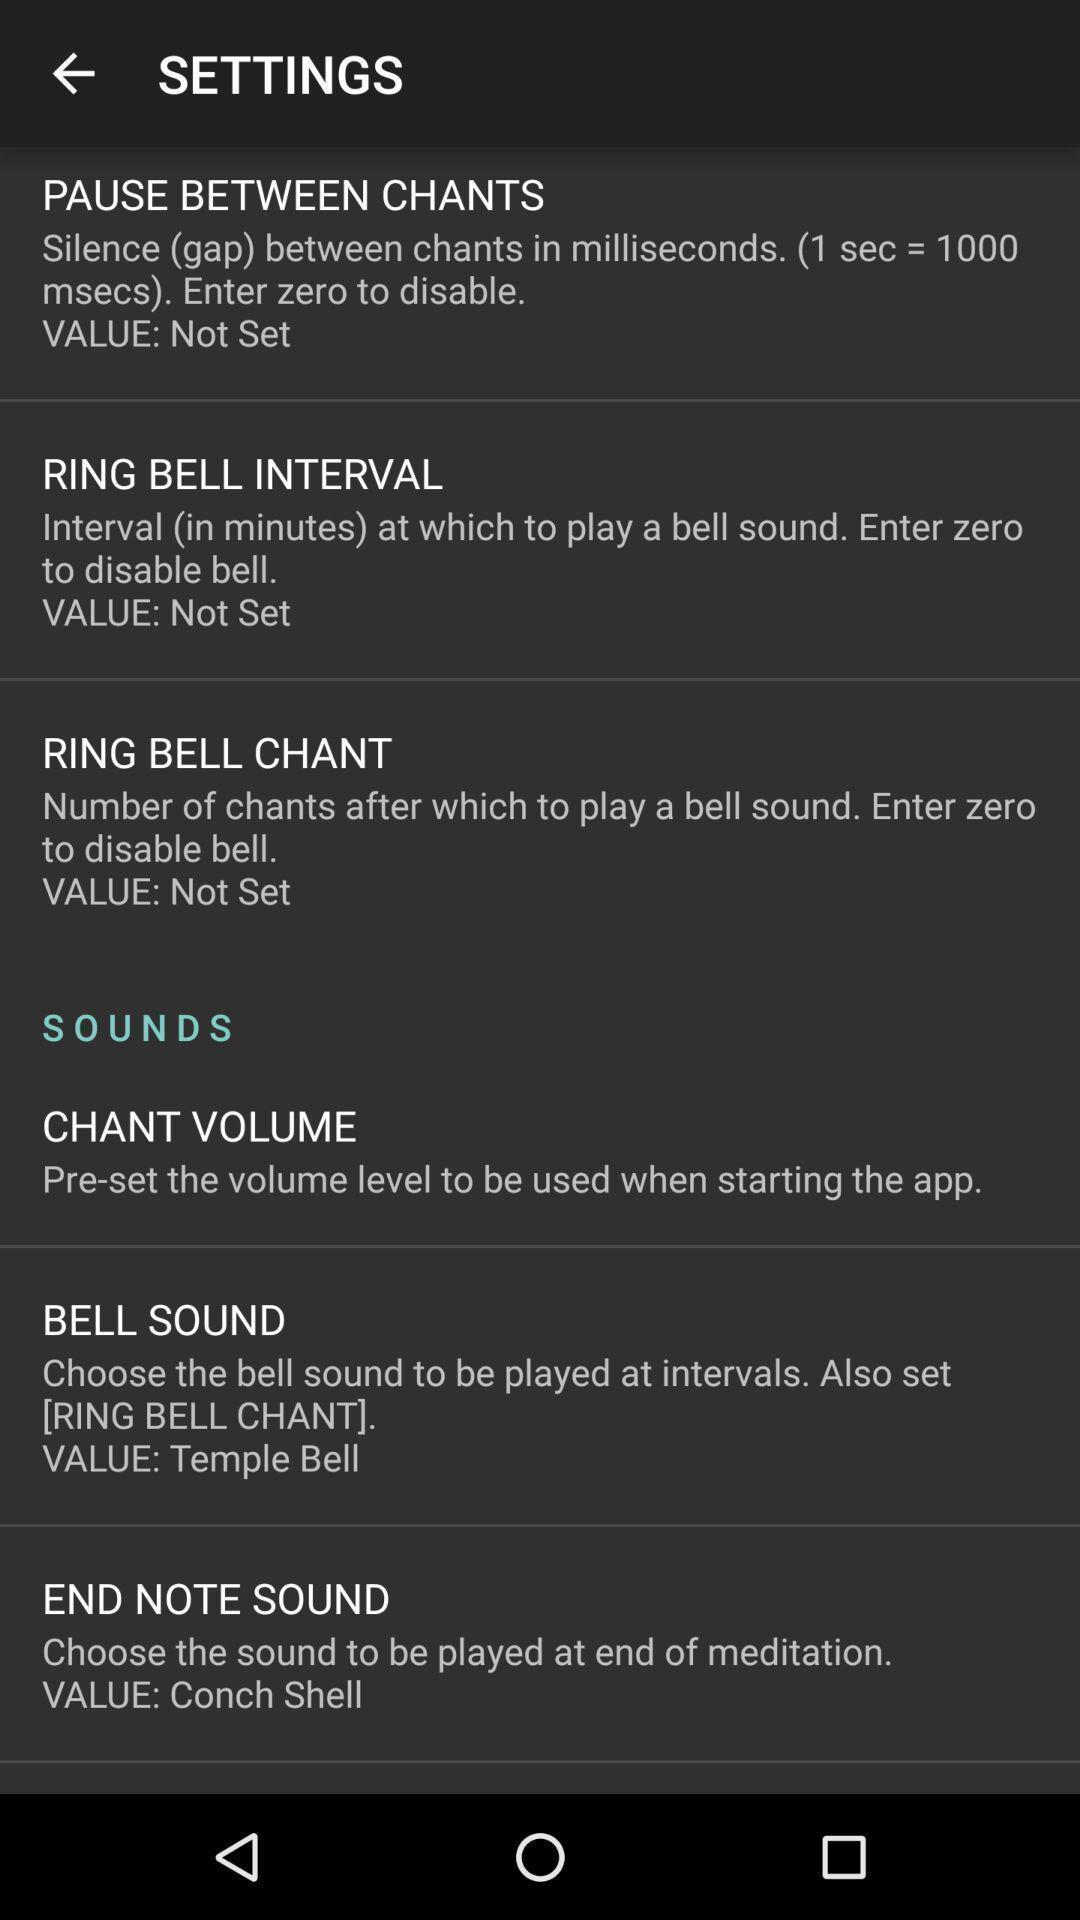Explain the elements present in this screenshot. Settings page displaying. 